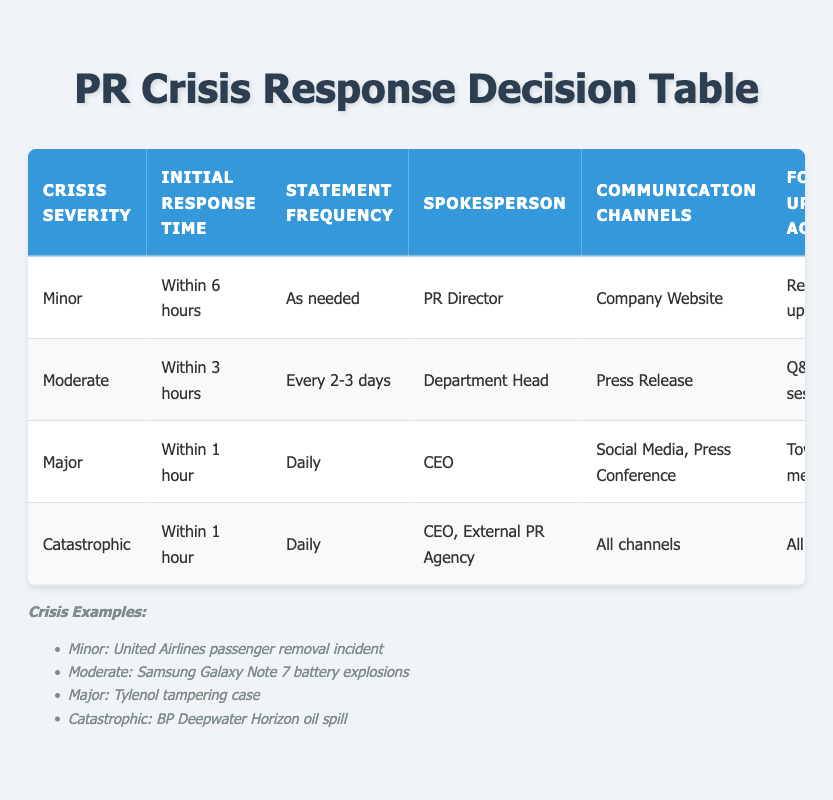What is the initial response time for a minor crisis? From the table, we locate the row for a minor crisis, which states the initial response time as "Within 6 hours."
Answer: Within 6 hours Who is the spokesperson for a major crisis? Looking at the row for major crises, the table identifies the spokesperson as "CEO."
Answer: CEO What statement frequency is recommended for a catastrophic crisis? The table indicates that for a catastrophic crisis, the statement frequency is "Daily."
Answer: Daily Is the tone of statements for a moderate crisis reassuring? The tone for moderate crises is listed as "Reassuring" in the table, confirming that the statement tone is indeed reassuring.
Answer: Yes How many different spokesperson roles are involved in a catastrophic crisis? The catastrophic crisis row mentions two spokesperson roles: "CEO" and "External PR Agency." Hence, there are two roles in this case.
Answer: 2 What is the difference in initial response time between a major and a minor crisis? The major crisis requires a response "Within 1 hour," while a minor crisis requires "Within 6 hours." The difference is 6 hours - 1 hour, totaling 5 hours.
Answer: 5 hours For which crisis severity is there high stakeholder engagement? The table indicates high stakeholder engagement for both major and catastrophic crises when checking the corresponding rows.
Answer: Major and Catastrophic Are regular updates a follow-up action for minor crises? Referring to the table, for minor crises the follow-up action listed is "Regular updates," indicating that this is accurate.
Answer: Yes Which communication channel is used for a moderate crisis? In the table, for a moderate crisis, the communication channel specified is "Press Release."
Answer: Press Release What is the average media monitoring frequency for minor and moderate crises? The frequencies are "Twice daily" for minor and "Every 4 hours" for moderate. Converting "Every 4 hours" to a daily frequency equals 6 times per day. Thus, we average totaling twice daily (2) plus six (6) times, divided by two: (2 + 6) / 2 = 4.
Answer: 4 times per day 